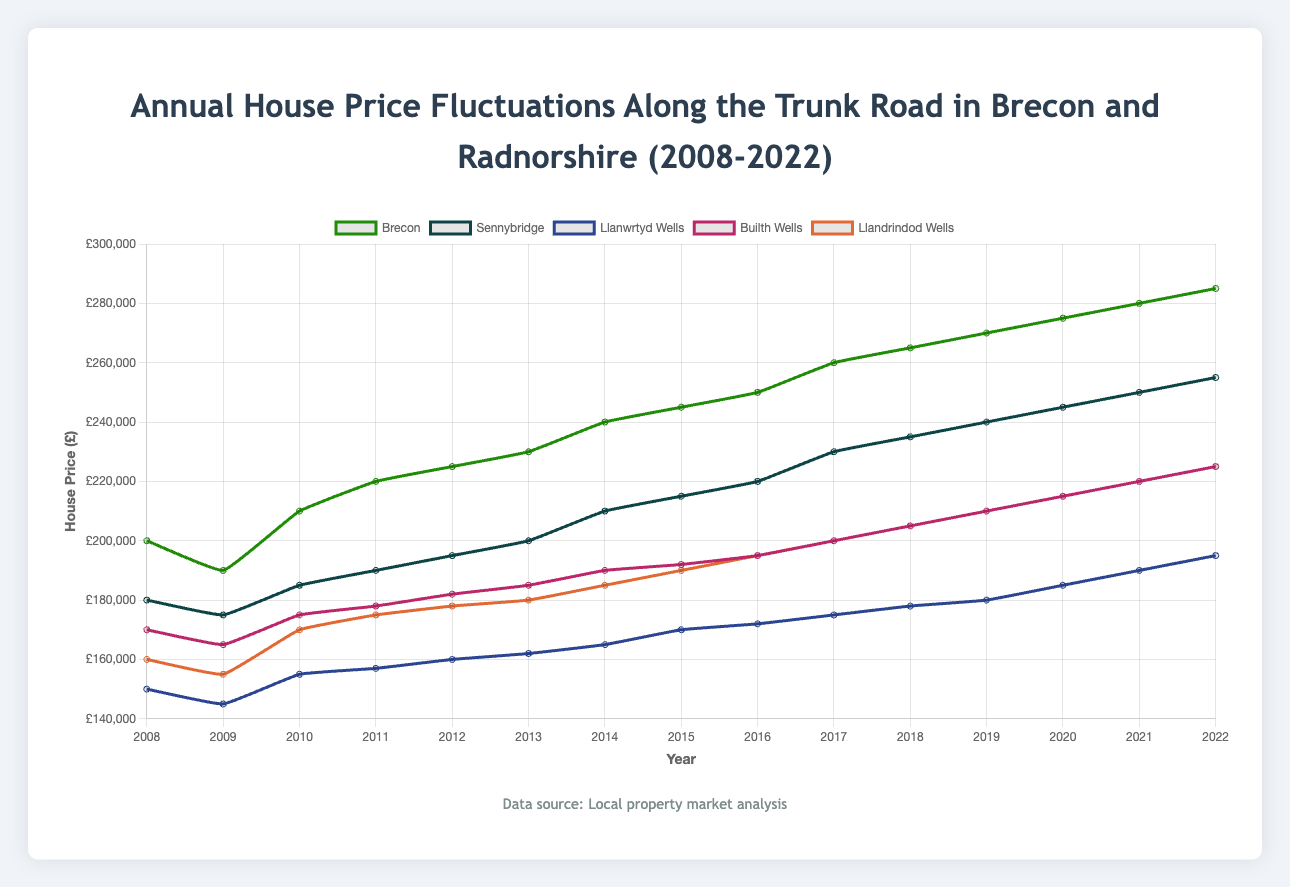What was the house price in Brecon in 2008 and 2022? According to the figure, the house price in Brecon was £200,000 in 2008 and £285,000 in 2022.
Answer: 200,000; 285,000 Which area experienced the highest increase in house prices between 2008 and 2022? The figure shows that Brecon experienced the highest increase in house prices, from £200,000 in 2008 to £285,000 in 2022, an increase of £85,000.
Answer: Brecon In which year did Llandrindod Wells first reach a house price of £200,000? By looking at the line for Llandrindod Wells, it first reaches £200,000 in 2017.
Answer: 2017 What's the average house price in Llanwrtyd Wells over the 15 years? Sum the house prices in Llanwrtyd Wells from 2008 to 2022 and then divide by 15. The total sum is £2,697,000, so the average is £2,697,000 / 15 = £179,800.
Answer: 179,800 Which area had the smallest difference in house prices between 2008 and 2022? Comparing the price differences, Llanwrtyd Wells had the smallest difference between 2008 and 2022, rising from £150,000 to £195,000, a difference of £45,000.
Answer: Llanwrtyd Wells Which year saw the lowest house price in Sennybridge? The lowest house price in Sennybridge occurred in 2009 at £175,000.
Answer: 2009 What's the combined house price of Builth Wells and Llandrindod Wells in 2010? In 2010, the house price in Builth Wells is £175,000 and in Llandrindod Wells is £170,000. Their combined price is £175,000 + £170,000 = £345,000.
Answer: 345,000 How many years did it take for the house prices in Brecon to rise from £200,000 to £250,000? Brecon house prices rose from £200,000 in 2008 to £250,000 in 2016. This took 8 years.
Answer: 8 years Which area had the most stable (least fluctuating) house price trend over the 15 years? Llanwrtyd Wells had the most stable trend, with relatively small yearly changes in house prices compared to other areas.
Answer: Llanwrtyd Wells 